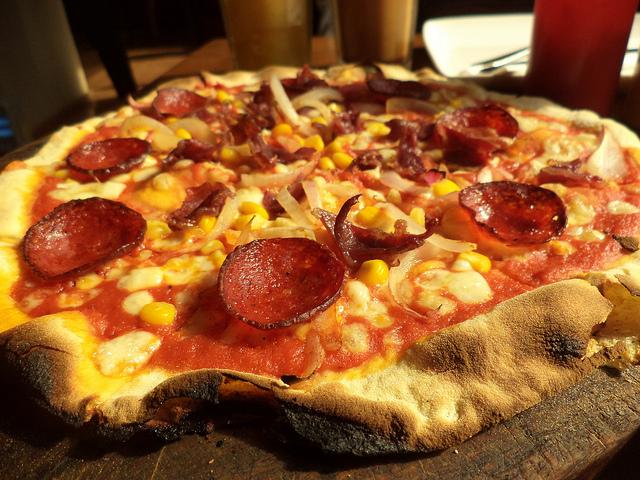Is this food for a vegetarian?
Keep it brief. No. Has someone taken a bite of this meal?
Quick response, please. No. Does this pizza have a crispy crust?
Write a very short answer. Yes. Is that pepperoni?
Keep it brief. Yes. Was this picture taken inside?
Concise answer only. Yes. 